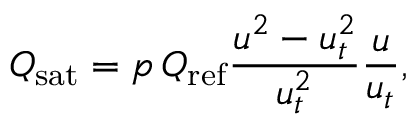<formula> <loc_0><loc_0><loc_500><loc_500>Q _ { s a t } = p \, Q _ { r e f } \frac { u ^ { 2 } - u _ { t } ^ { 2 } } { u _ { t } ^ { 2 } } \frac { u } { u _ { t } } ,</formula> 